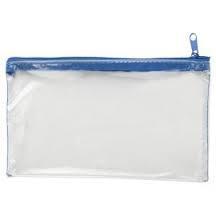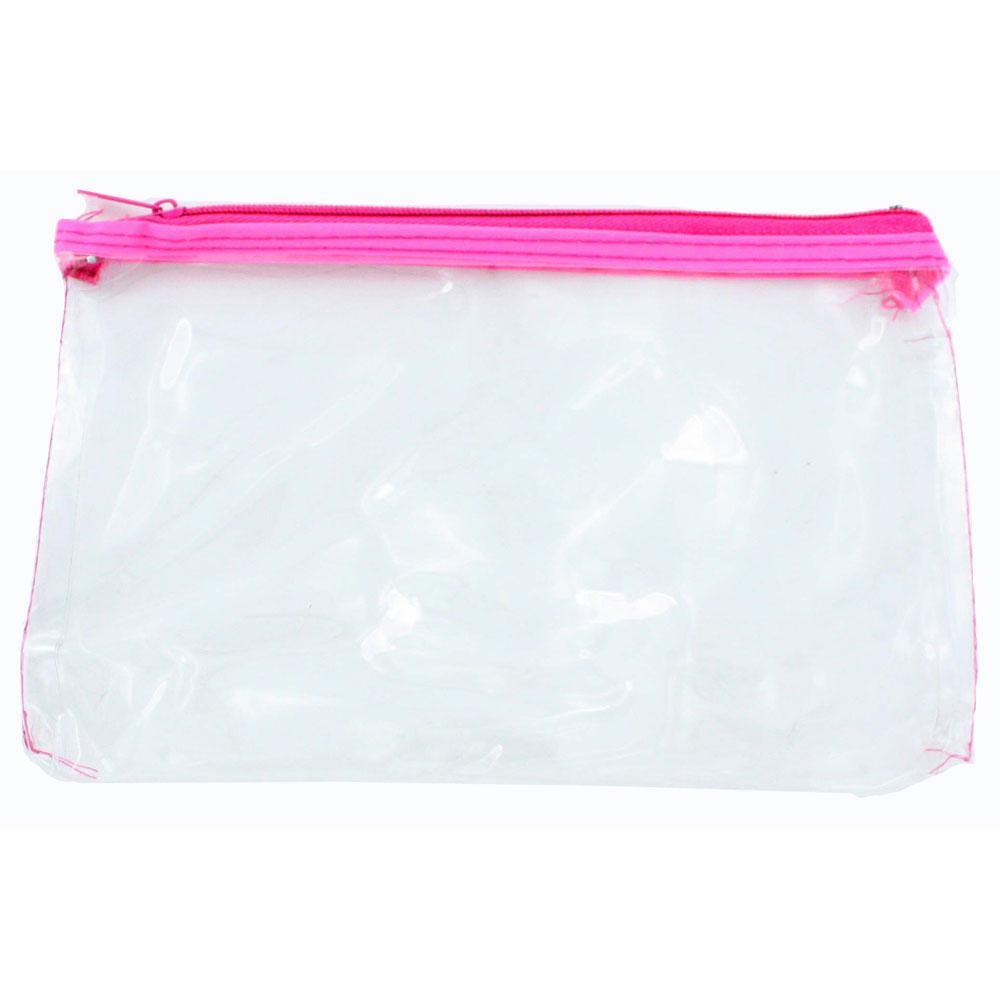The first image is the image on the left, the second image is the image on the right. For the images displayed, is the sentence "One clear pencil case has only a blue zipper on top, and one pencil case has at least a pink zipper across the top." factually correct? Answer yes or no. Yes. The first image is the image on the left, the second image is the image on the right. For the images displayed, is the sentence "There are 2 pencil cases, each with 1 zipper." factually correct? Answer yes or no. Yes. 